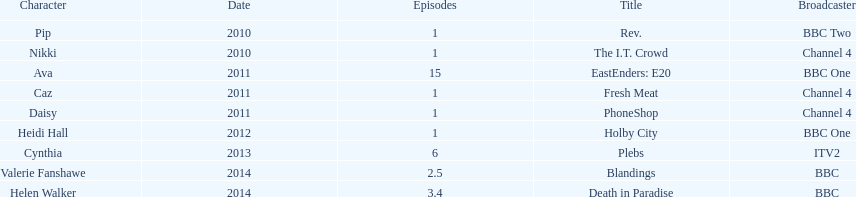Blandings and death in paradise both aired on which broadcaster? BBC. 